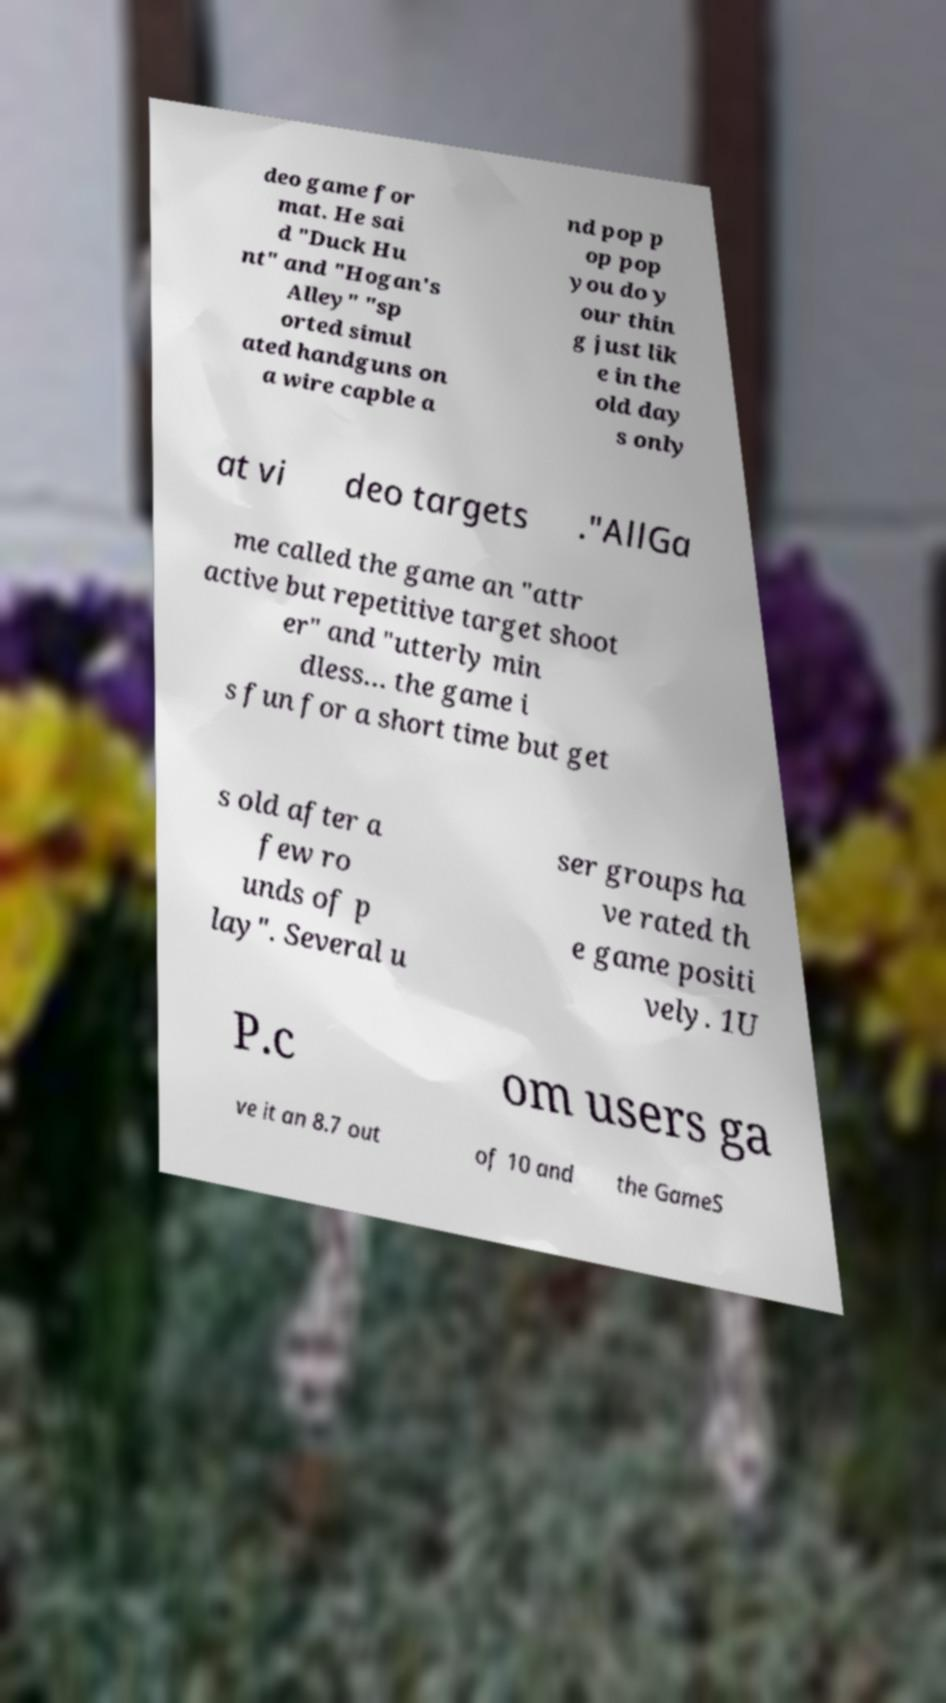Could you extract and type out the text from this image? deo game for mat. He sai d "Duck Hu nt" and "Hogan's Alley" "sp orted simul ated handguns on a wire capble a nd pop p op pop you do y our thin g just lik e in the old day s only at vi deo targets ."AllGa me called the game an "attr active but repetitive target shoot er" and "utterly min dless… the game i s fun for a short time but get s old after a few ro unds of p lay". Several u ser groups ha ve rated th e game positi vely. 1U P.c om users ga ve it an 8.7 out of 10 and the GameS 